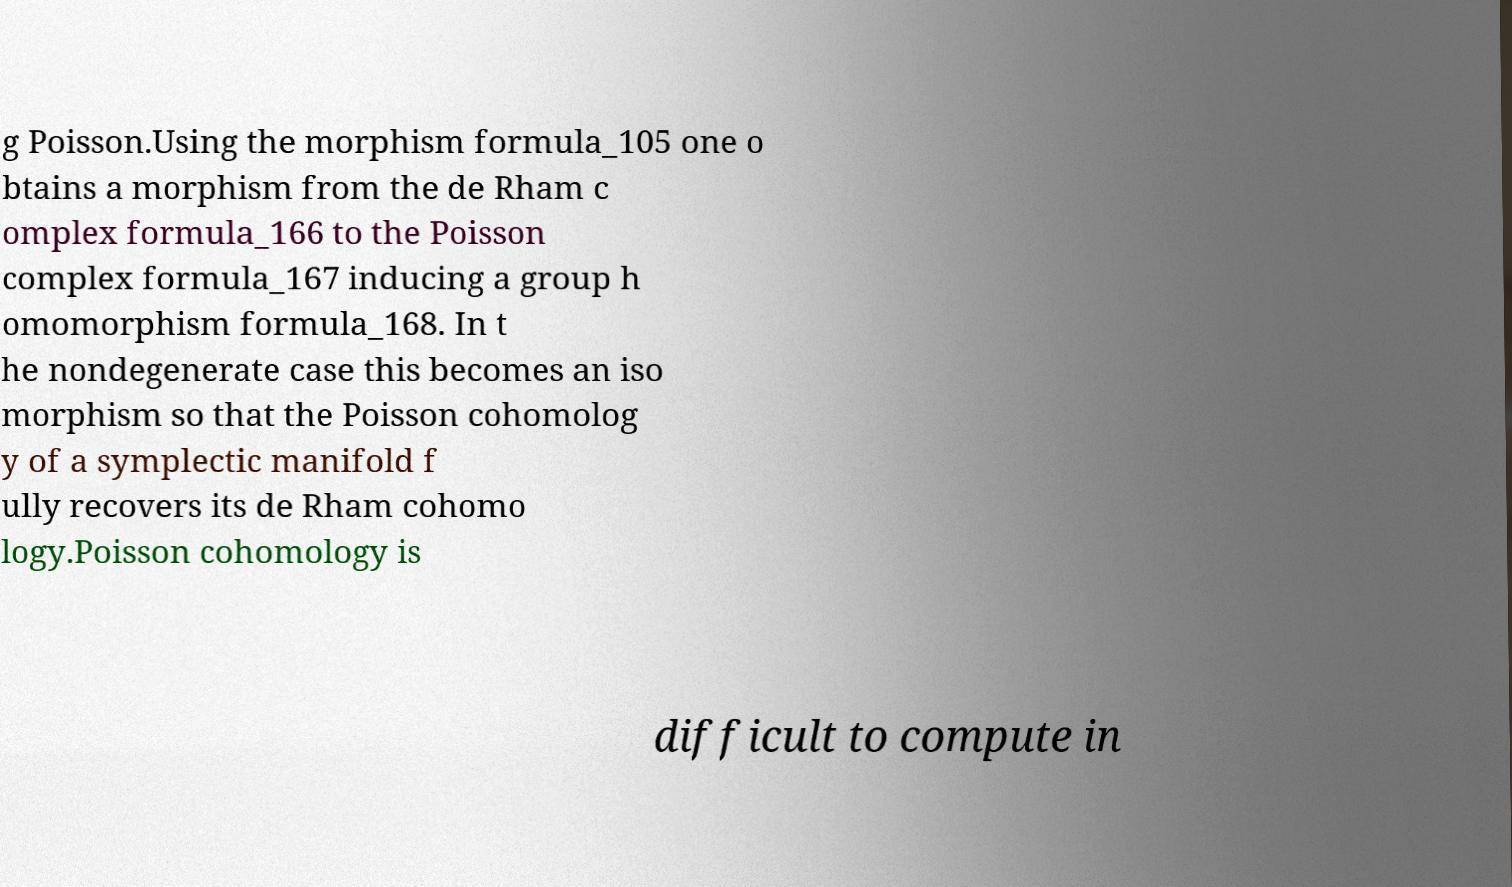What messages or text are displayed in this image? I need them in a readable, typed format. g Poisson.Using the morphism formula_105 one o btains a morphism from the de Rham c omplex formula_166 to the Poisson complex formula_167 inducing a group h omomorphism formula_168. In t he nondegenerate case this becomes an iso morphism so that the Poisson cohomolog y of a symplectic manifold f ully recovers its de Rham cohomo logy.Poisson cohomology is difficult to compute in 